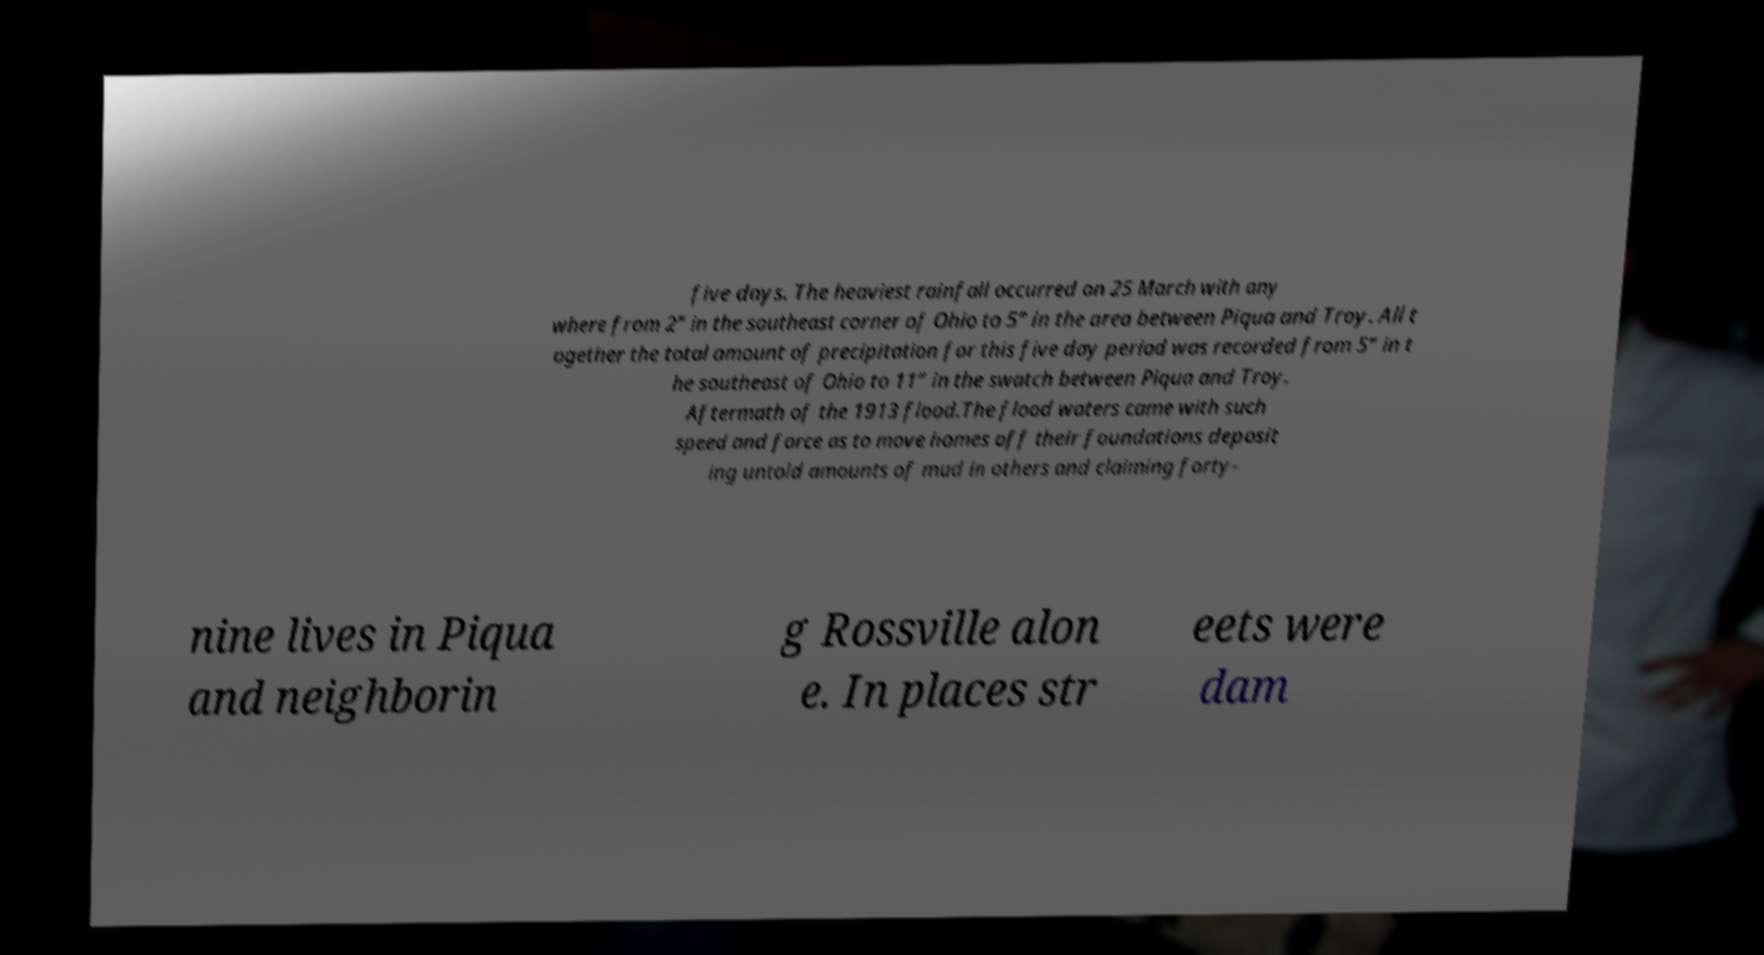I need the written content from this picture converted into text. Can you do that? five days. The heaviest rainfall occurred on 25 March with any where from 2” in the southeast corner of Ohio to 5” in the area between Piqua and Troy. All t ogether the total amount of precipitation for this five day period was recorded from 5” in t he southeast of Ohio to 11” in the swatch between Piqua and Troy. Aftermath of the 1913 flood.The flood waters came with such speed and force as to move homes off their foundations deposit ing untold amounts of mud in others and claiming forty- nine lives in Piqua and neighborin g Rossville alon e. In places str eets were dam 